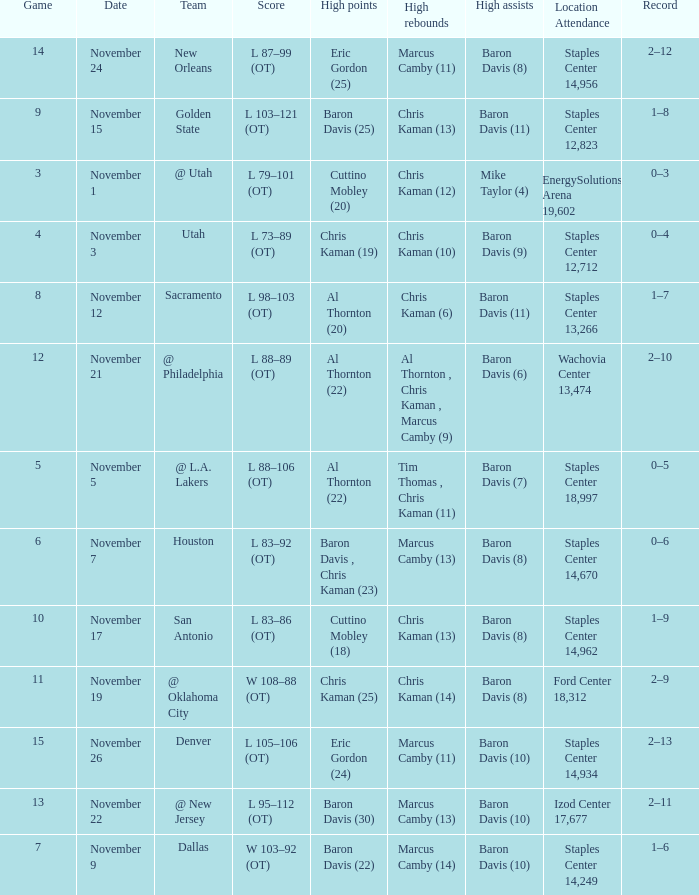Name the total number of score for staples center 13,266 1.0. 